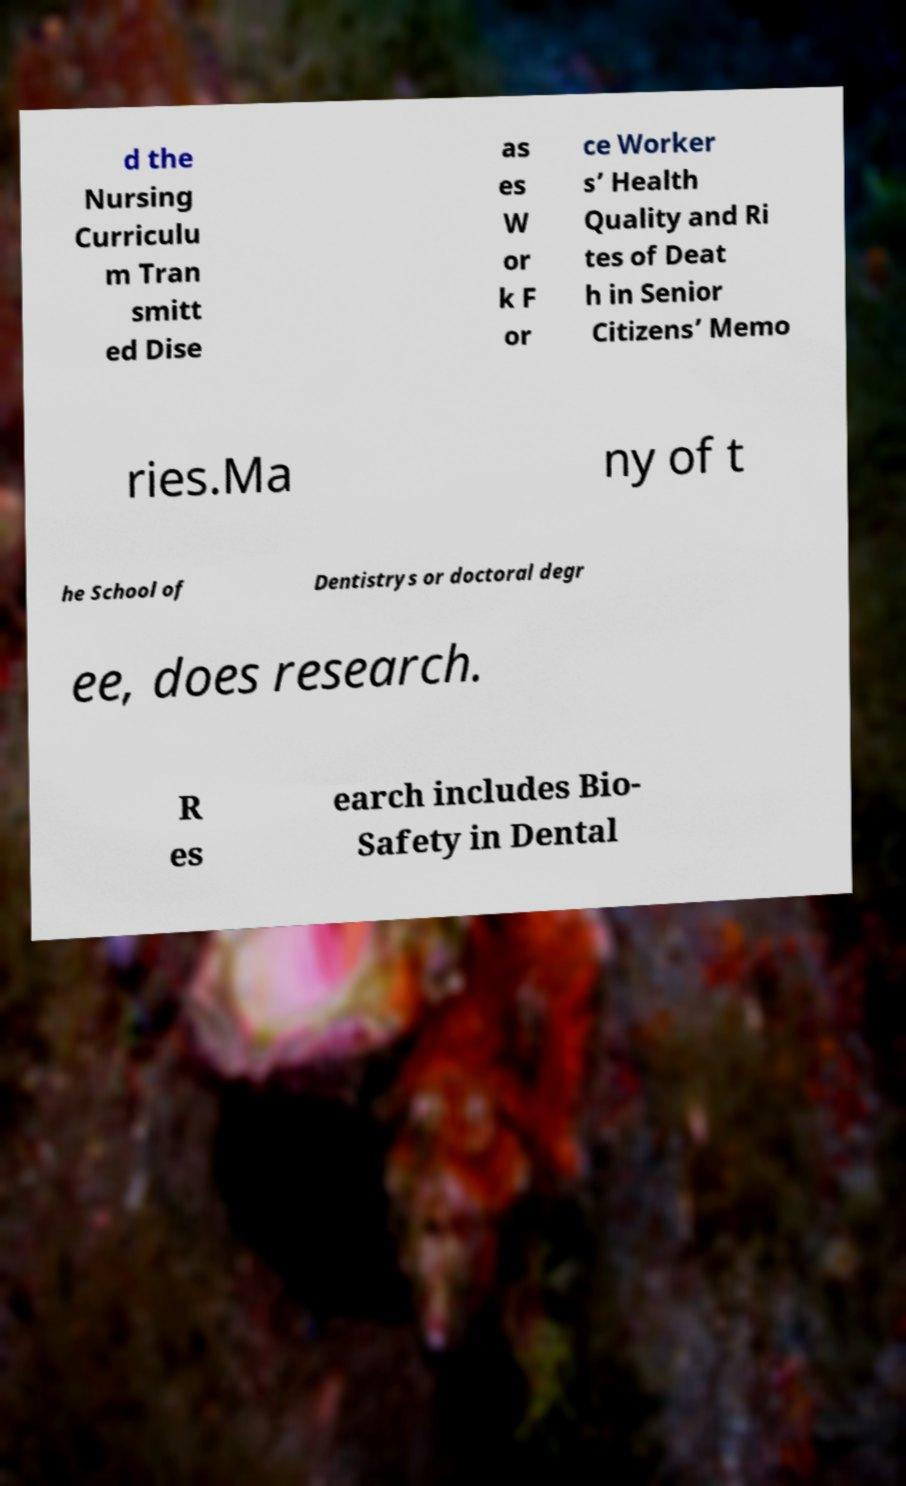Could you extract and type out the text from this image? d the Nursing Curriculu m Tran smitt ed Dise as es W or k F or ce Worker s’ Health Quality and Ri tes of Deat h in Senior Citizens’ Memo ries.Ma ny of t he School of Dentistrys or doctoral degr ee, does research. R es earch includes Bio- Safety in Dental 